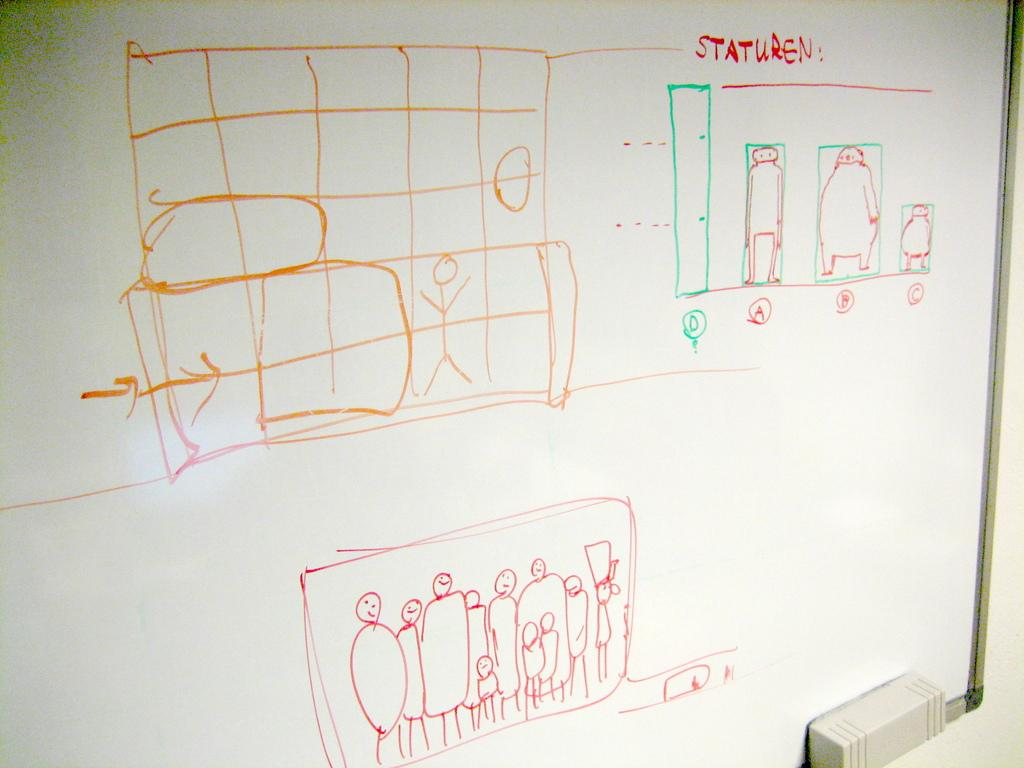What is the main object in the image? There is a whiteboard in the image. What is depicted on the whiteboard? There is a sketch on the whiteboard. Can you describe the object in the bottom right corner of the image? There is an object in the bottom right corner of the image, but its details are not clear from the provided facts. What else can be seen in the image besides the whiteboard? There is a wall visible in the image. What attempt is being made to coil the object in the image? There is no attempt to coil any object in the image, as the provided facts do not mention any such action or object. How does the person in the image express their hate towards the sketch on the whiteboard? There is no indication of any emotion, such as hate, towards the sketch on the whiteboard in the image. 